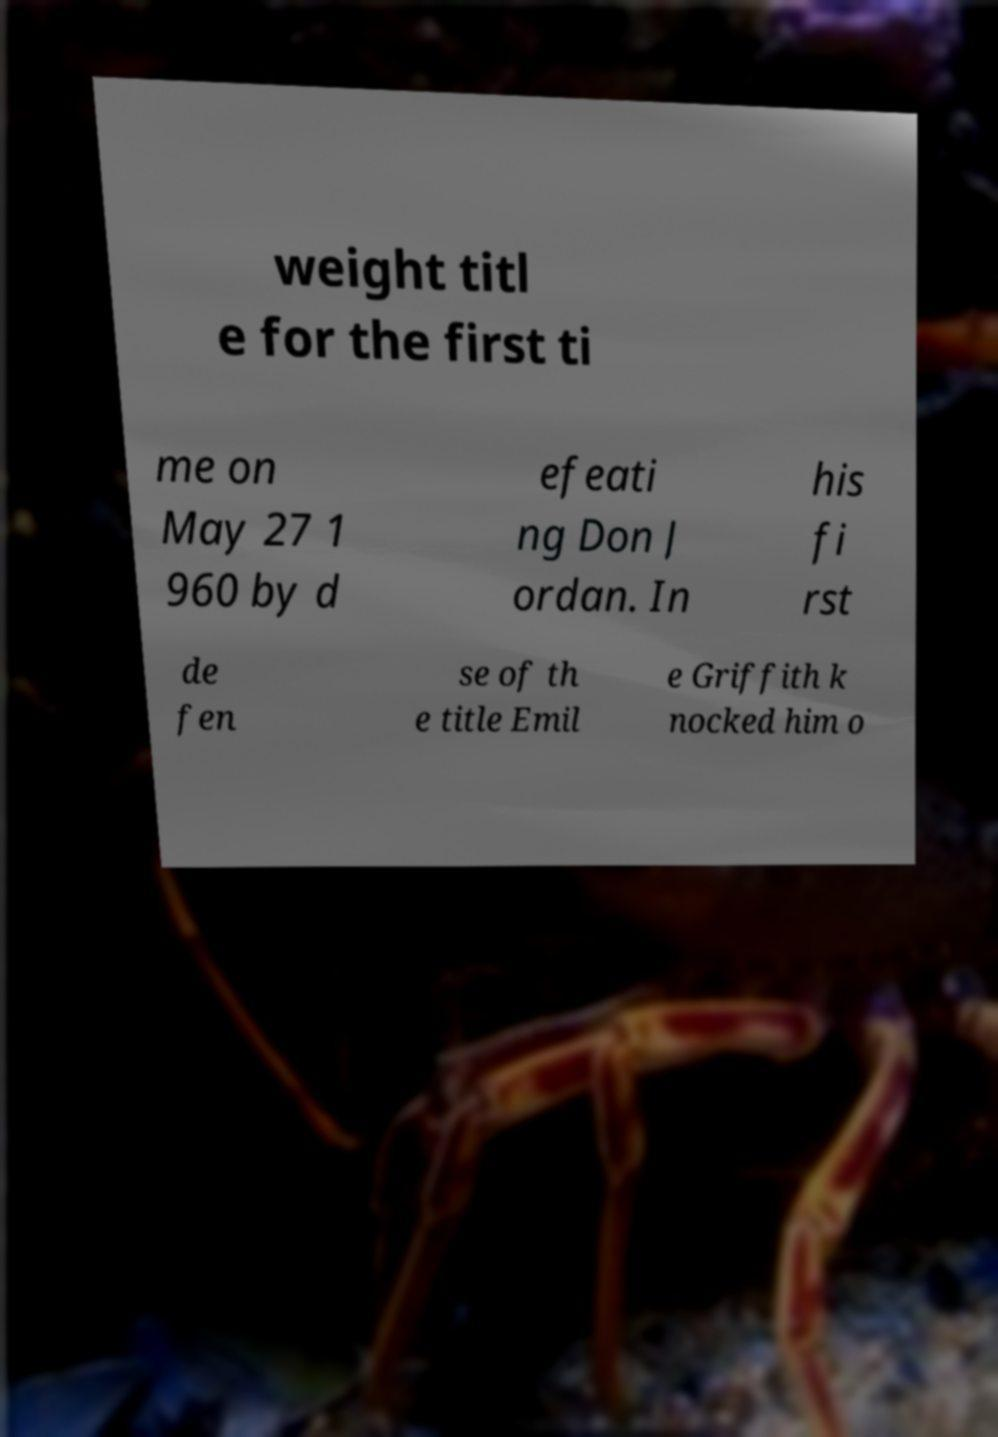Could you extract and type out the text from this image? weight titl e for the first ti me on May 27 1 960 by d efeati ng Don J ordan. In his fi rst de fen se of th e title Emil e Griffith k nocked him o 